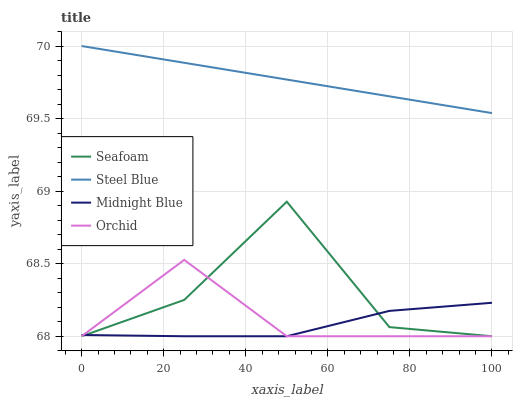Does Midnight Blue have the minimum area under the curve?
Answer yes or no. Yes. Does Steel Blue have the maximum area under the curve?
Answer yes or no. Yes. Does Seafoam have the minimum area under the curve?
Answer yes or no. No. Does Seafoam have the maximum area under the curve?
Answer yes or no. No. Is Steel Blue the smoothest?
Answer yes or no. Yes. Is Seafoam the roughest?
Answer yes or no. Yes. Is Midnight Blue the smoothest?
Answer yes or no. No. Is Midnight Blue the roughest?
Answer yes or no. No. Does Orchid have the lowest value?
Answer yes or no. Yes. Does Steel Blue have the lowest value?
Answer yes or no. No. Does Steel Blue have the highest value?
Answer yes or no. Yes. Does Seafoam have the highest value?
Answer yes or no. No. Is Orchid less than Steel Blue?
Answer yes or no. Yes. Is Steel Blue greater than Midnight Blue?
Answer yes or no. Yes. Does Seafoam intersect Orchid?
Answer yes or no. Yes. Is Seafoam less than Orchid?
Answer yes or no. No. Is Seafoam greater than Orchid?
Answer yes or no. No. Does Orchid intersect Steel Blue?
Answer yes or no. No. 